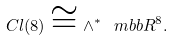<formula> <loc_0><loc_0><loc_500><loc_500>C l ( 8 ) \cong { \wedge } ^ { * } \, \ m b b R ^ { 8 } .</formula> 